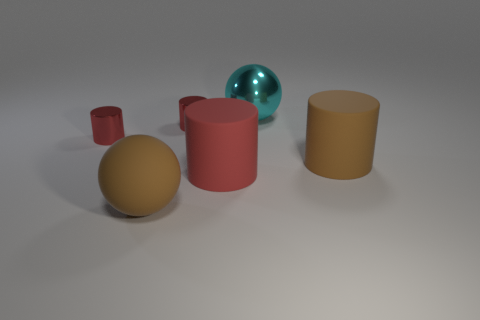There is a brown rubber object that is in front of the big brown matte cylinder; what is its shape?
Offer a very short reply. Sphere. There is a brown matte thing that is on the right side of the red matte thing behind the big matte sphere; how many large matte objects are behind it?
Provide a short and direct response. 0. Does the brown sphere have the same size as the brown object to the right of the red matte object?
Make the answer very short. Yes. What size is the red object that is in front of the big rubber cylinder that is behind the big red thing?
Offer a terse response. Large. What number of brown things have the same material as the large red thing?
Keep it short and to the point. 2. Is there a tiny yellow rubber block?
Ensure brevity in your answer.  No. What is the size of the ball that is behind the large red rubber cylinder?
Offer a very short reply. Large. How many big cylinders have the same color as the matte ball?
Offer a very short reply. 1. How many balls are red rubber objects or big matte objects?
Your answer should be compact. 1. What shape is the object that is both behind the rubber ball and in front of the brown rubber cylinder?
Ensure brevity in your answer.  Cylinder. 